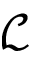Convert formula to latex. <formula><loc_0><loc_0><loc_500><loc_500>\mathcal { L }</formula> 